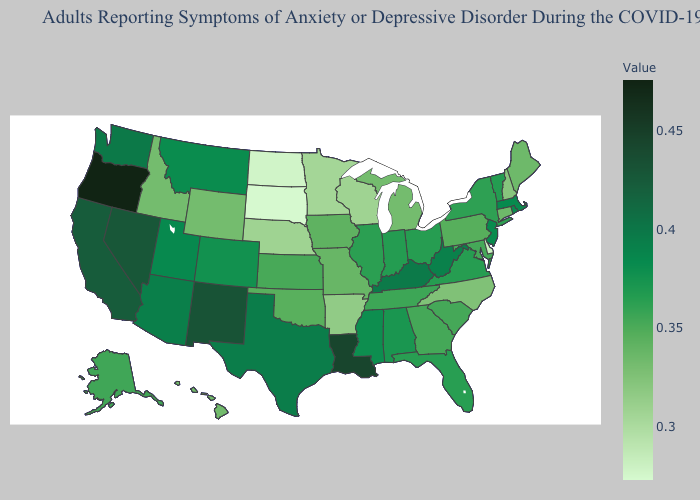Does Pennsylvania have the highest value in the Northeast?
Short answer required. No. Among the states that border Connecticut , which have the lowest value?
Keep it brief. New York. Is the legend a continuous bar?
Short answer required. Yes. Does Delaware have the lowest value in the South?
Give a very brief answer. Yes. Which states hav the highest value in the West?
Short answer required. Oregon. Does New Mexico have the lowest value in the USA?
Concise answer only. No. Which states hav the highest value in the West?
Keep it brief. Oregon. Which states have the lowest value in the West?
Short answer required. Idaho, Wyoming. 